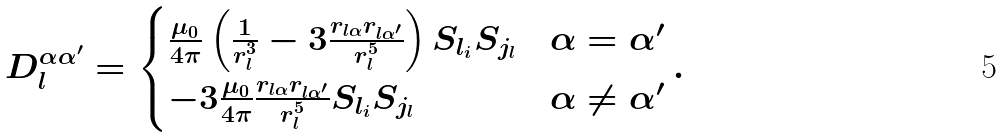<formula> <loc_0><loc_0><loc_500><loc_500>D _ { l } ^ { \alpha \alpha ^ { \prime } } = \begin{cases} \frac { \mu _ { 0 } } { 4 \pi } \left ( \frac { 1 } { r _ { l } ^ { 3 } } - 3 \frac { r _ { l \alpha } r _ { l \alpha ^ { \prime } } } { r _ { l } ^ { 5 } } \right ) S _ { l _ { i } } S _ { j _ { l } } & \alpha = \alpha ^ { \prime } \\ - 3 \frac { \mu _ { 0 } } { 4 \pi } \frac { r _ { l \alpha } r _ { l \alpha ^ { \prime } } } { r _ { l } ^ { 5 } } S _ { l _ { i } } S _ { j _ { l } } & \alpha \neq \alpha ^ { \prime } \end{cases} .</formula> 